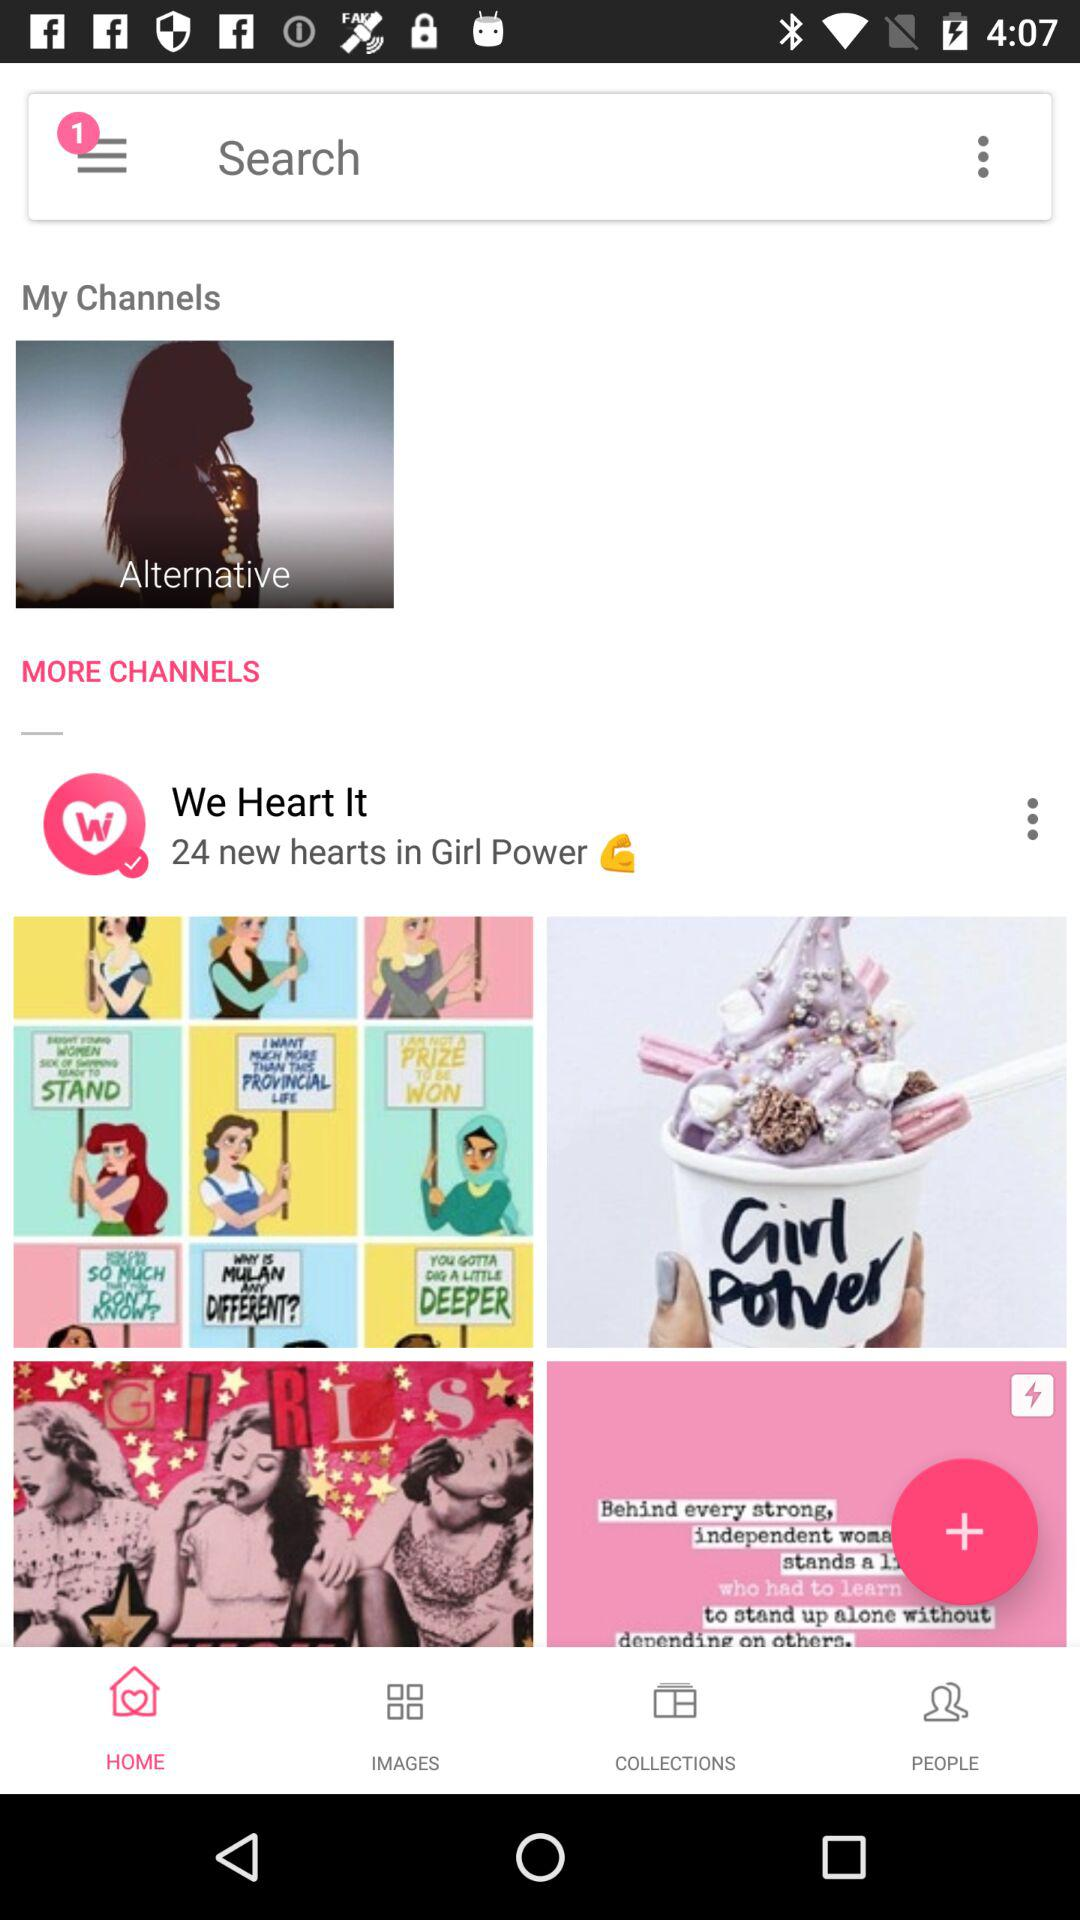How many unread notifications are there? There is 1 unread notification. 